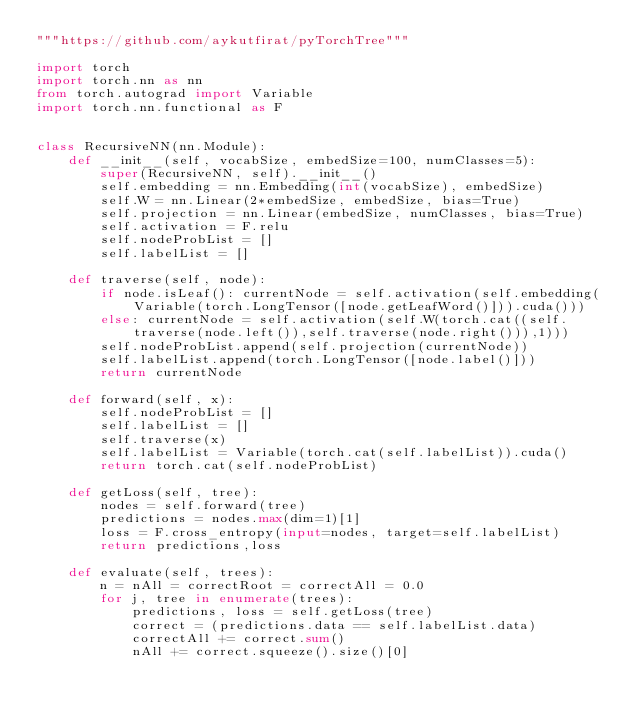Convert code to text. <code><loc_0><loc_0><loc_500><loc_500><_Python_>"""https://github.com/aykutfirat/pyTorchTree"""

import torch
import torch.nn as nn
from torch.autograd import Variable
import torch.nn.functional as F


class RecursiveNN(nn.Module):
    def __init__(self, vocabSize, embedSize=100, numClasses=5):
        super(RecursiveNN, self).__init__()
        self.embedding = nn.Embedding(int(vocabSize), embedSize)
        self.W = nn.Linear(2*embedSize, embedSize, bias=True)
        self.projection = nn.Linear(embedSize, numClasses, bias=True)
        self.activation = F.relu
        self.nodeProbList = []
        self.labelList = []

    def traverse(self, node):
        if node.isLeaf(): currentNode = self.activation(self.embedding(Variable(torch.LongTensor([node.getLeafWord()])).cuda()))
        else: currentNode = self.activation(self.W(torch.cat((self.traverse(node.left()),self.traverse(node.right())),1)))
        self.nodeProbList.append(self.projection(currentNode))
        self.labelList.append(torch.LongTensor([node.label()]))
        return currentNode

    def forward(self, x):
        self.nodeProbList = []
        self.labelList = []
        self.traverse(x)
        self.labelList = Variable(torch.cat(self.labelList)).cuda()
        return torch.cat(self.nodeProbList)

    def getLoss(self, tree):
        nodes = self.forward(tree)
        predictions = nodes.max(dim=1)[1]
        loss = F.cross_entropy(input=nodes, target=self.labelList)
        return predictions,loss

    def evaluate(self, trees):
        n = nAll = correctRoot = correctAll = 0.0
        for j, tree in enumerate(trees):
            predictions, loss = self.getLoss(tree)
            correct = (predictions.data == self.labelList.data)
            correctAll += correct.sum()
            nAll += correct.squeeze().size()[0]</code> 